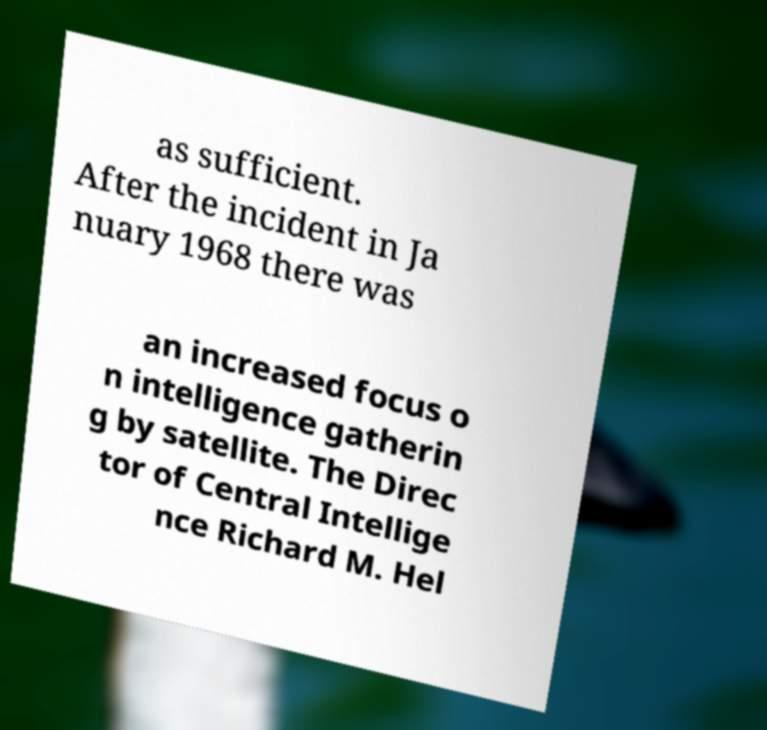Please read and relay the text visible in this image. What does it say? as sufficient. After the incident in Ja nuary 1968 there was an increased focus o n intelligence gatherin g by satellite. The Direc tor of Central Intellige nce Richard M. Hel 